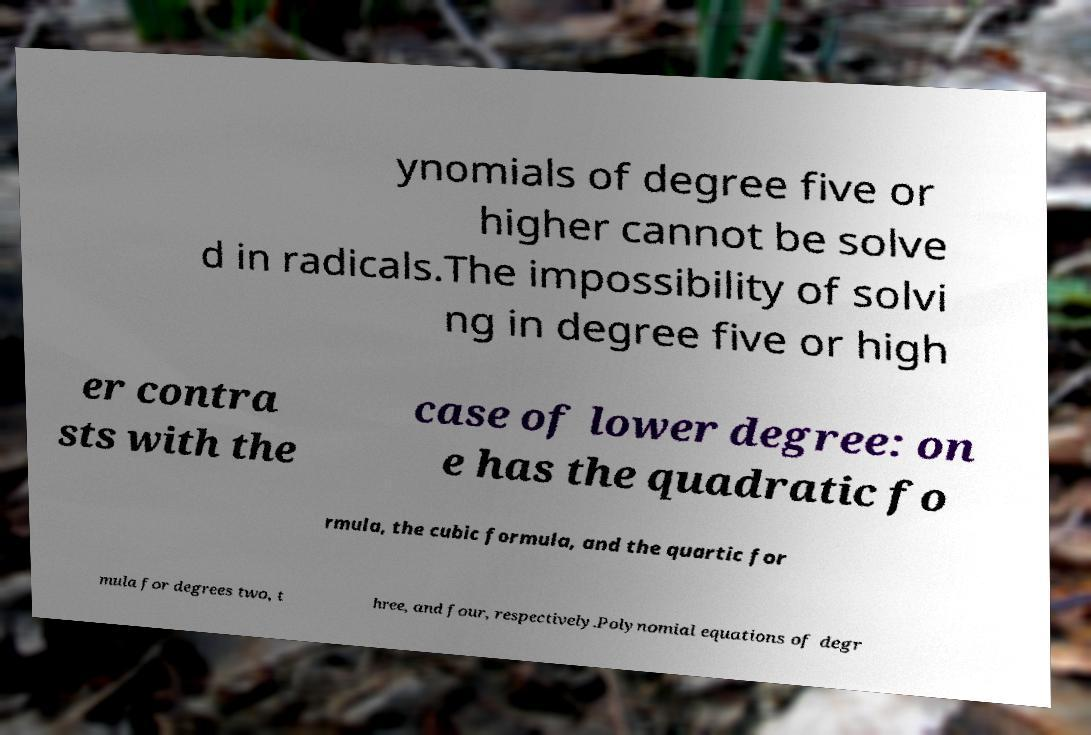Can you accurately transcribe the text from the provided image for me? ynomials of degree five or higher cannot be solve d in radicals.The impossibility of solvi ng in degree five or high er contra sts with the case of lower degree: on e has the quadratic fo rmula, the cubic formula, and the quartic for mula for degrees two, t hree, and four, respectively.Polynomial equations of degr 